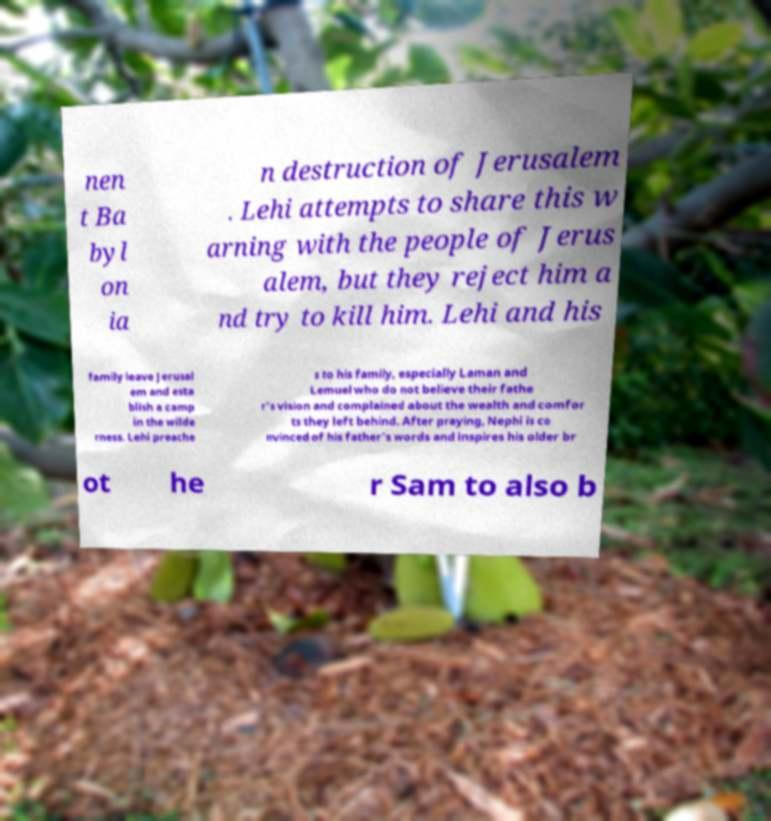I need the written content from this picture converted into text. Can you do that? nen t Ba byl on ia n destruction of Jerusalem . Lehi attempts to share this w arning with the people of Jerus alem, but they reject him a nd try to kill him. Lehi and his family leave Jerusal em and esta blish a camp in the wilde rness. Lehi preache s to his family, especially Laman and Lemuel who do not believe their fathe r's vision and complained about the wealth and comfor ts they left behind. After praying, Nephi is co nvinced of his father's words and inspires his older br ot he r Sam to also b 